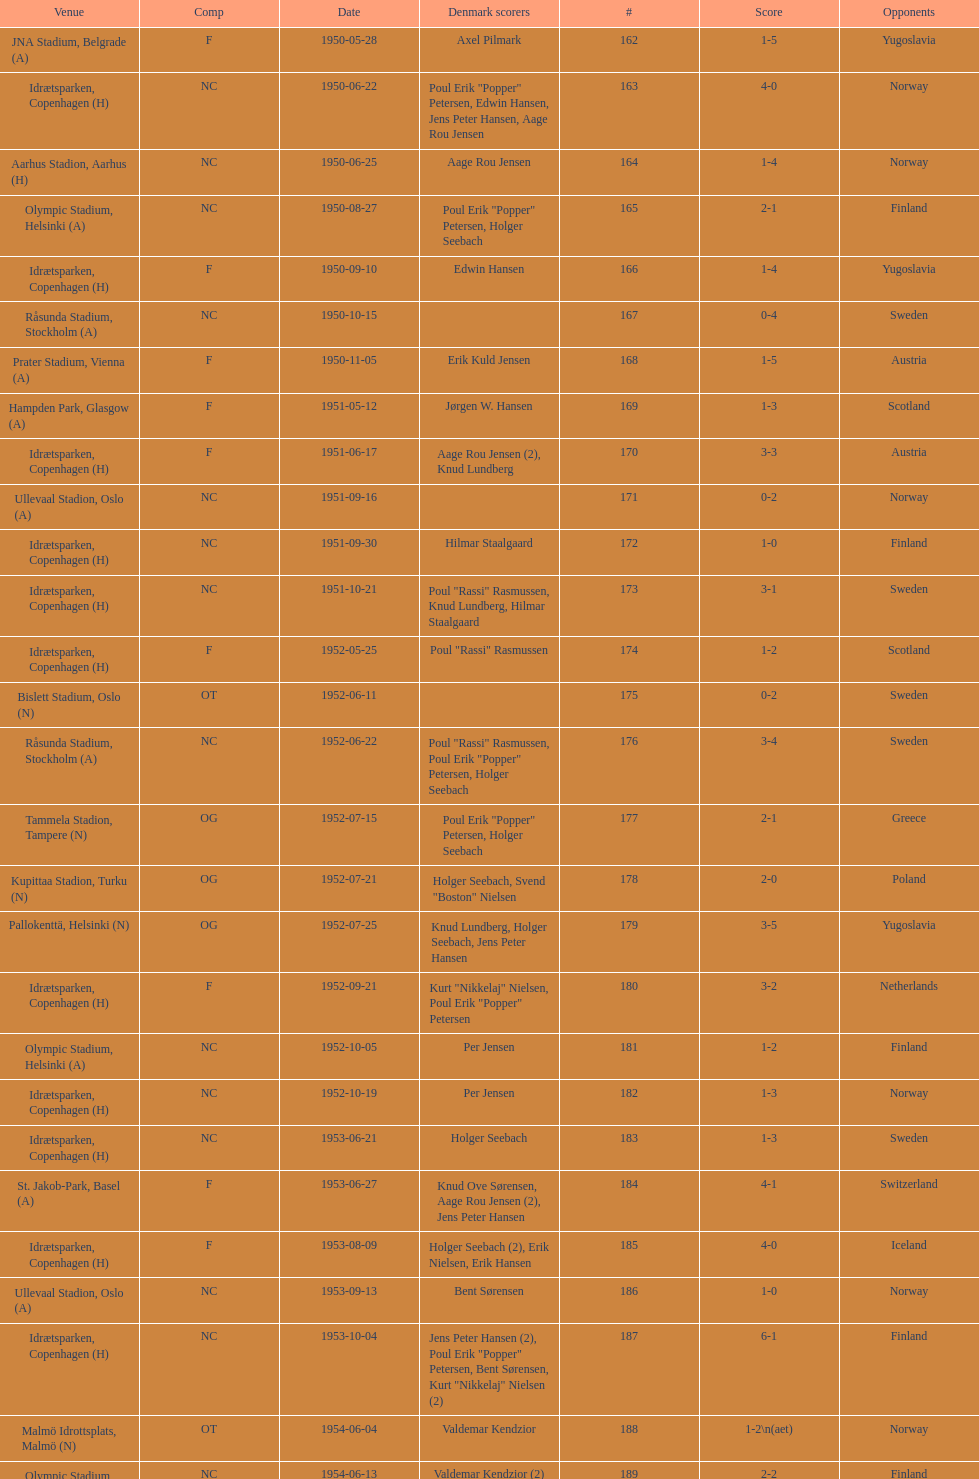Give me the full table as a dictionary. {'header': ['Venue', 'Comp', 'Date', 'Denmark scorers', '#', 'Score', 'Opponents'], 'rows': [['JNA Stadium, Belgrade (A)', 'F', '1950-05-28', 'Axel Pilmark', '162', '1-5', 'Yugoslavia'], ['Idrætsparken, Copenhagen (H)', 'NC', '1950-06-22', 'Poul Erik "Popper" Petersen, Edwin Hansen, Jens Peter Hansen, Aage Rou Jensen', '163', '4-0', 'Norway'], ['Aarhus Stadion, Aarhus (H)', 'NC', '1950-06-25', 'Aage Rou Jensen', '164', '1-4', 'Norway'], ['Olympic Stadium, Helsinki (A)', 'NC', '1950-08-27', 'Poul Erik "Popper" Petersen, Holger Seebach', '165', '2-1', 'Finland'], ['Idrætsparken, Copenhagen (H)', 'F', '1950-09-10', 'Edwin Hansen', '166', '1-4', 'Yugoslavia'], ['Råsunda Stadium, Stockholm (A)', 'NC', '1950-10-15', '', '167', '0-4', 'Sweden'], ['Prater Stadium, Vienna (A)', 'F', '1950-11-05', 'Erik Kuld Jensen', '168', '1-5', 'Austria'], ['Hampden Park, Glasgow (A)', 'F', '1951-05-12', 'Jørgen W. Hansen', '169', '1-3', 'Scotland'], ['Idrætsparken, Copenhagen (H)', 'F', '1951-06-17', 'Aage Rou Jensen (2), Knud Lundberg', '170', '3-3', 'Austria'], ['Ullevaal Stadion, Oslo (A)', 'NC', '1951-09-16', '', '171', '0-2', 'Norway'], ['Idrætsparken, Copenhagen (H)', 'NC', '1951-09-30', 'Hilmar Staalgaard', '172', '1-0', 'Finland'], ['Idrætsparken, Copenhagen (H)', 'NC', '1951-10-21', 'Poul "Rassi" Rasmussen, Knud Lundberg, Hilmar Staalgaard', '173', '3-1', 'Sweden'], ['Idrætsparken, Copenhagen (H)', 'F', '1952-05-25', 'Poul "Rassi" Rasmussen', '174', '1-2', 'Scotland'], ['Bislett Stadium, Oslo (N)', 'OT', '1952-06-11', '', '175', '0-2', 'Sweden'], ['Råsunda Stadium, Stockholm (A)', 'NC', '1952-06-22', 'Poul "Rassi" Rasmussen, Poul Erik "Popper" Petersen, Holger Seebach', '176', '3-4', 'Sweden'], ['Tammela Stadion, Tampere (N)', 'OG', '1952-07-15', 'Poul Erik "Popper" Petersen, Holger Seebach', '177', '2-1', 'Greece'], ['Kupittaa Stadion, Turku (N)', 'OG', '1952-07-21', 'Holger Seebach, Svend "Boston" Nielsen', '178', '2-0', 'Poland'], ['Pallokenttä, Helsinki (N)', 'OG', '1952-07-25', 'Knud Lundberg, Holger Seebach, Jens Peter Hansen', '179', '3-5', 'Yugoslavia'], ['Idrætsparken, Copenhagen (H)', 'F', '1952-09-21', 'Kurt "Nikkelaj" Nielsen, Poul Erik "Popper" Petersen', '180', '3-2', 'Netherlands'], ['Olympic Stadium, Helsinki (A)', 'NC', '1952-10-05', 'Per Jensen', '181', '1-2', 'Finland'], ['Idrætsparken, Copenhagen (H)', 'NC', '1952-10-19', 'Per Jensen', '182', '1-3', 'Norway'], ['Idrætsparken, Copenhagen (H)', 'NC', '1953-06-21', 'Holger Seebach', '183', '1-3', 'Sweden'], ['St. Jakob-Park, Basel (A)', 'F', '1953-06-27', 'Knud Ove Sørensen, Aage Rou Jensen (2), Jens Peter Hansen', '184', '4-1', 'Switzerland'], ['Idrætsparken, Copenhagen (H)', 'F', '1953-08-09', 'Holger Seebach (2), Erik Nielsen, Erik Hansen', '185', '4-0', 'Iceland'], ['Ullevaal Stadion, Oslo (A)', 'NC', '1953-09-13', 'Bent Sørensen', '186', '1-0', 'Norway'], ['Idrætsparken, Copenhagen (H)', 'NC', '1953-10-04', 'Jens Peter Hansen (2), Poul Erik "Popper" Petersen, Bent Sørensen, Kurt "Nikkelaj" Nielsen (2)', '187', '6-1', 'Finland'], ['Malmö Idrottsplats, Malmö (N)', 'OT', '1954-06-04', 'Valdemar Kendzior', '188', '1-2\\n(aet)', 'Norway'], ['Olympic Stadium, Helsinki (A)', 'NC', '1954-06-13', 'Valdemar Kendzior (2)', '189', '2-2', 'Finland'], ['Idrætsparken, Copenhagen (H)', 'F', '1954-09-19', 'Jørgen Olesen', '190', '1-1', 'Switzerland'], ['Råsunda Stadium, Stockholm (A)', 'NC', '1954-10-10', 'Jens Peter Hansen, Bent Sørensen', '191', '2-5', 'Sweden'], ['Idrætsparken, Copenhagen (H)', 'NC', '1954-10-31', '', '192', '0-1', 'Norway'], ['Olympic Stadium, Amsterdam (A)', 'F', '1955-03-13', 'Vagn Birkeland', '193', '1-1', 'Netherlands'], ['Idrætsparken, Copenhagen (H)', 'F', '1955-05-15', '', '194', '0-6', 'Hungary'], ['Idrætsparken, Copenhagen (H)', 'NC', '1955-06-19', 'Jens Peter Hansen (2)', '195', '2-1', 'Finland'], ['Melavollur, Reykjavík (A)', 'F', '1955-06-03', 'Aage Rou Jensen, Jens Peter Hansen, Poul Pedersen (2)', '196', '4-0', 'Iceland'], ['Ullevaal Stadion, Oslo (A)', 'NC', '1955-09-11', 'Jørgen Jacobsen', '197', '1-1', 'Norway'], ['Idrætsparken, Copenhagen (H)', 'NC', '1955-10-02', 'Knud Lundberg', '198', '1-5', 'England'], ['Idrætsparken, Copenhagen (H)', 'NC', '1955-10-16', 'Ove Andersen (2), Knud Lundberg', '199', '3-3', 'Sweden'], ['Dynamo Stadium, Moscow (A)', 'F', '1956-05-23', 'Knud Lundberg', '200', '1-5', 'USSR'], ['Idrætsparken, Copenhagen (H)', 'NC', '1956-06-24', 'Knud Lundberg, Poul Pedersen', '201', '2-3', 'Norway'], ['Idrætsparken, Copenhagen (H)', 'F', '1956-07-01', 'Ove Andersen, Aage Rou Jensen', '202', '2-5', 'USSR'], ['Olympic Stadium, Helsinki (A)', 'NC', '1956-09-16', 'Poul Pedersen, Jørgen Hansen, Ove Andersen (2)', '203', '4-0', 'Finland'], ['Dalymount Park, Dublin (A)', 'WCQ', '1956-10-03', 'Aage Rou Jensen', '204', '1-2', 'Republic of Ireland'], ['Råsunda Stadium, Stockholm (A)', 'NC', '1956-10-21', 'Jens Peter Hansen', '205', '1-1', 'Sweden'], ['Idrætsparken, Copenhagen (H)', 'F', '1956-11-04', 'Jørgen Olesen, Knud Lundberg', '206', '2-2', 'Netherlands'], ['Molineux, Wolverhampton (A)', 'WCQ', '1956-12-05', 'Ove Bech Nielsen (2)', '207', '2-5', 'England'], ['Idrætsparken, Copenhagen (H)', 'WCQ', '1957-05-15', 'John Jensen', '208', '1-4', 'England'], ['Idrætsparken, Copenhagen (H)', 'F', '1957-05-26', 'Aage Rou Jensen', '209', '1-1', 'Bulgaria'], ['Olympic Stadium, Helsinki (A)', 'OT', '1957-06-18', '', '210', '0-2', 'Finland'], ['Tammela Stadion, Tampere (N)', 'OT', '1957-06-19', 'Egon Jensen, Jørgen Hansen', '211', '2-0', 'Norway'], ['Idrætsparken, Copenhagen (H)', 'NC', '1957-06-30', 'Jens Peter Hansen', '212', '1-2', 'Sweden'], ['Laugardalsvöllur, Reykjavík (A)', 'OT', '1957-07-10', 'Egon Jensen (3), Poul Pedersen, Jens Peter Hansen (2)', '213', '6-2', 'Iceland'], ['Ullevaal Stadion, Oslo (A)', 'NC', '1957-09-22', 'Poul Pedersen, Peder Kjær', '214', '2-2', 'Norway'], ['Idrætsparken, Copenhagen (H)', 'WCQ', '1957-10-02', '', '215', '0-2', 'Republic of Ireland'], ['Idrætsparken, Copenhagen (H)', 'NC', '1957-10-13', 'Finn Alfred Hansen, Ove Bech Nielsen, Mogens Machon', '216', '3-0', 'Finland'], ['Aarhus Stadion, Aarhus (H)', 'F', '1958-05-15', 'Poul Pedersen, Henning Enoksen (2)', '217', '3-2', 'Curaçao'], ['Idrætsparken, Copenhagen (H)', 'F', '1958-05-25', 'Jørn Sørensen, Poul Pedersen (2)', '218', '3-2', 'Poland'], ['Idrætsparken, Copenhagen (H)', 'NC', '1958-06-29', 'Poul Pedersen', '219', '1-2', 'Norway'], ['Olympic Stadium, Helsinki (A)', 'NC', '1958-09-14', 'Poul Pedersen, Mogens Machon, John Danielsen (2)', '220', '4-1', 'Finland'], ['Idrætsparken, Copenhagen (H)', 'F', '1958-09-24', 'Henning Enoksen', '221', '1-1', 'West Germany'], ['Idrætsparken, Copenhagen (H)', 'F', '1958-10-15', 'Henning Enoksen', '222', '1-5', 'Netherlands'], ['Råsunda Stadium, Stockholm (A)', 'NC', '1958-10-26', 'Ole Madsen (2), Henning Enoksen, Jørn Sørensen', '223', '4-4', 'Sweden'], ['Idrætsparken, Copenhagen (H)', 'NC', '1959-06-21', '', '224', '0-6', 'Sweden'], ['Laugardalsvöllur, Reykjavík (A)', 'OGQ', '1959-06-26', 'Jens Peter Hansen (2), Ole Madsen (2)', '225', '4-2', 'Iceland'], ['Idrætsparken, Copenhagen (H)', 'OGQ', '1959-07-02', 'Henning Enoksen, Ole Madsen', '226', '2-1', 'Norway'], ['Idrætsparken, Copenhagen (H)', 'OGQ', '1959-08-18', 'Henning Enoksen', '227', '1-1', 'Iceland'], ['Ullevaal Stadion, Oslo (A)', 'OGQ\\nNC', '1959-09-13', 'Harald Nielsen, Henning Enoksen (2), Poul Pedersen', '228', '4-2', 'Norway'], ['Idrætsparken, Copenhagen (H)', 'ENQ', '1959-09-23', 'Poul Pedersen, Bent Hansen', '229', '2-2', 'Czechoslovakia'], ['Idrætsparken, Copenhagen (H)', 'NC', '1959-10-04', 'Harald Nielsen (3), John Kramer', '230', '4-0', 'Finland'], ['Stadion Za Lužánkami, Brno (A)', 'ENQ', '1959-10-18', 'John Kramer', '231', '1-5', 'Czechoslovakia'], ['Olympic Stadium, Athens (A)', 'F', '1959-12-02', 'Henning Enoksen (2), Poul Pedersen', '232', '3-1', 'Greece'], ['Vasil Levski National Stadium, Sofia (A)', 'F', '1959-12-06', 'Henning Enoksen', '233', '1-2', 'Bulgaria']]} Who did they play in the game listed directly above july 25, 1952? Poland. 